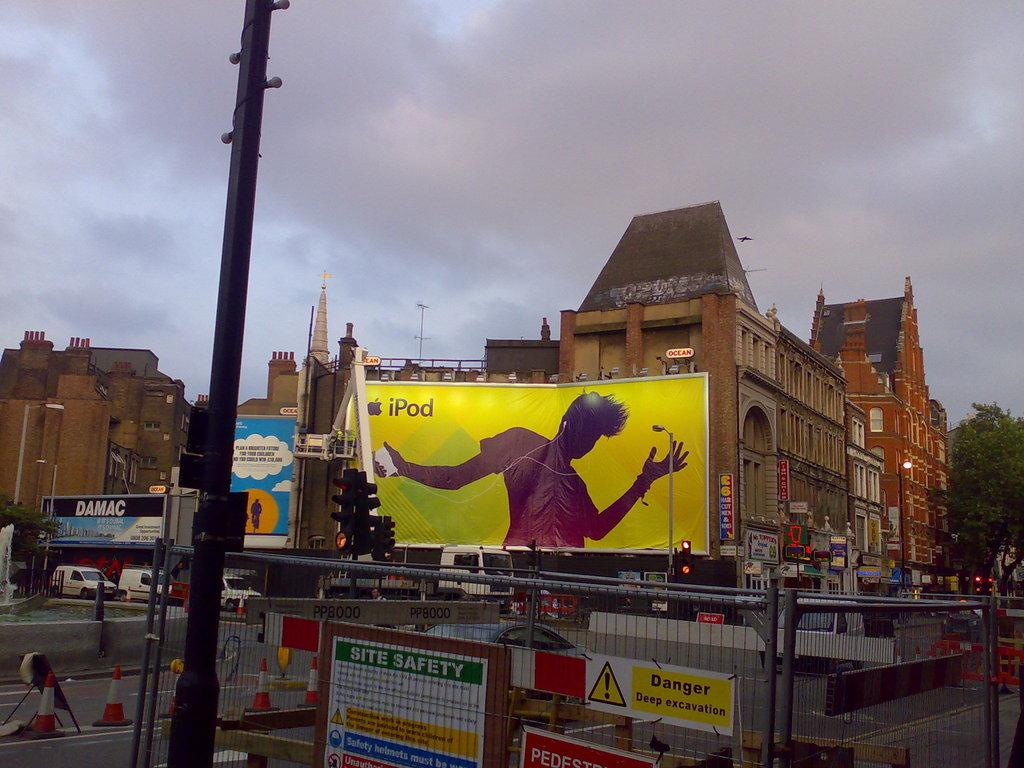<image>
Present a compact description of the photo's key features. Signs on a fence detail site safety and danger warnings. 